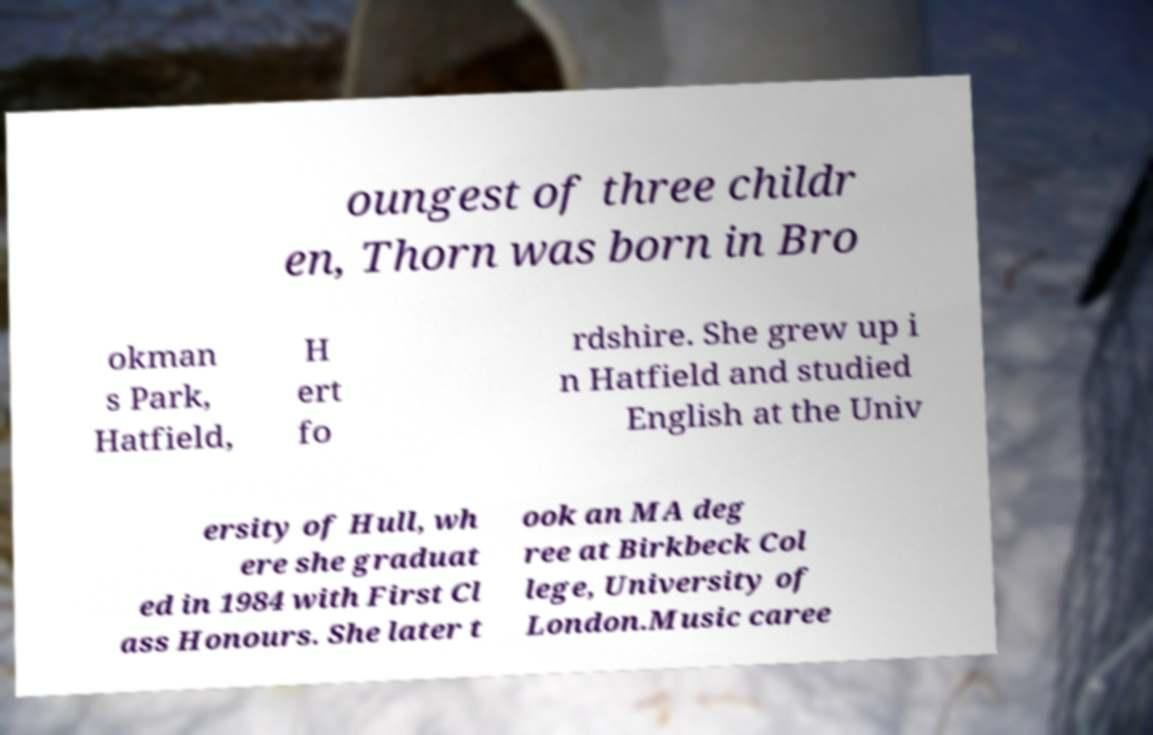Could you extract and type out the text from this image? oungest of three childr en, Thorn was born in Bro okman s Park, Hatfield, H ert fo rdshire. She grew up i n Hatfield and studied English at the Univ ersity of Hull, wh ere she graduat ed in 1984 with First Cl ass Honours. She later t ook an MA deg ree at Birkbeck Col lege, University of London.Music caree 